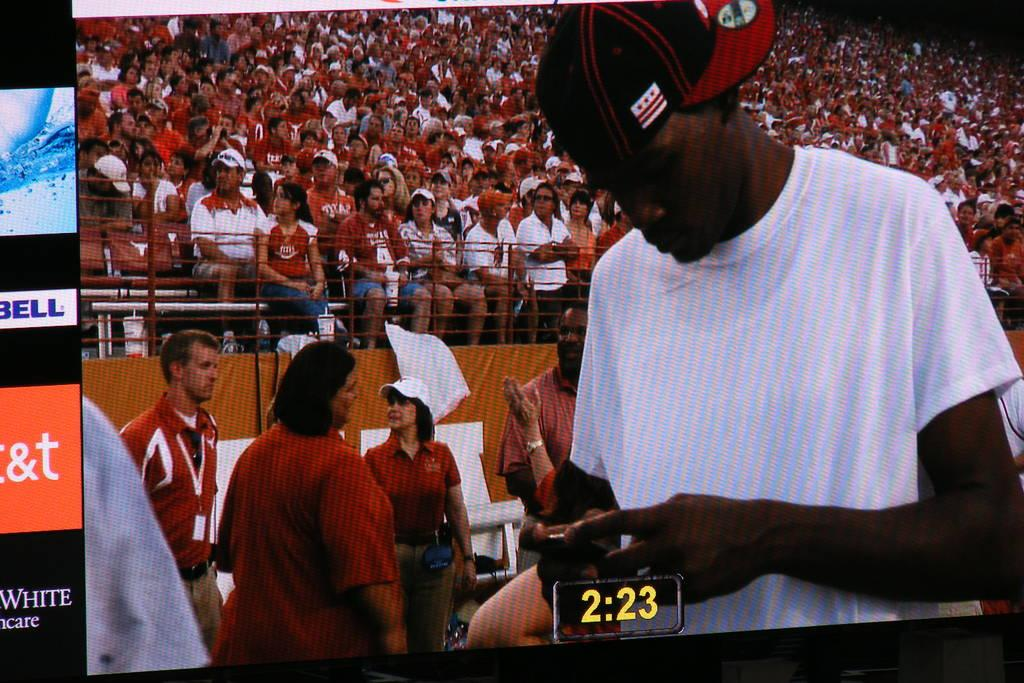<image>
Share a concise interpretation of the image provided. A man is on screen looking at his phone, and "2:23" is displayed beneath him. 